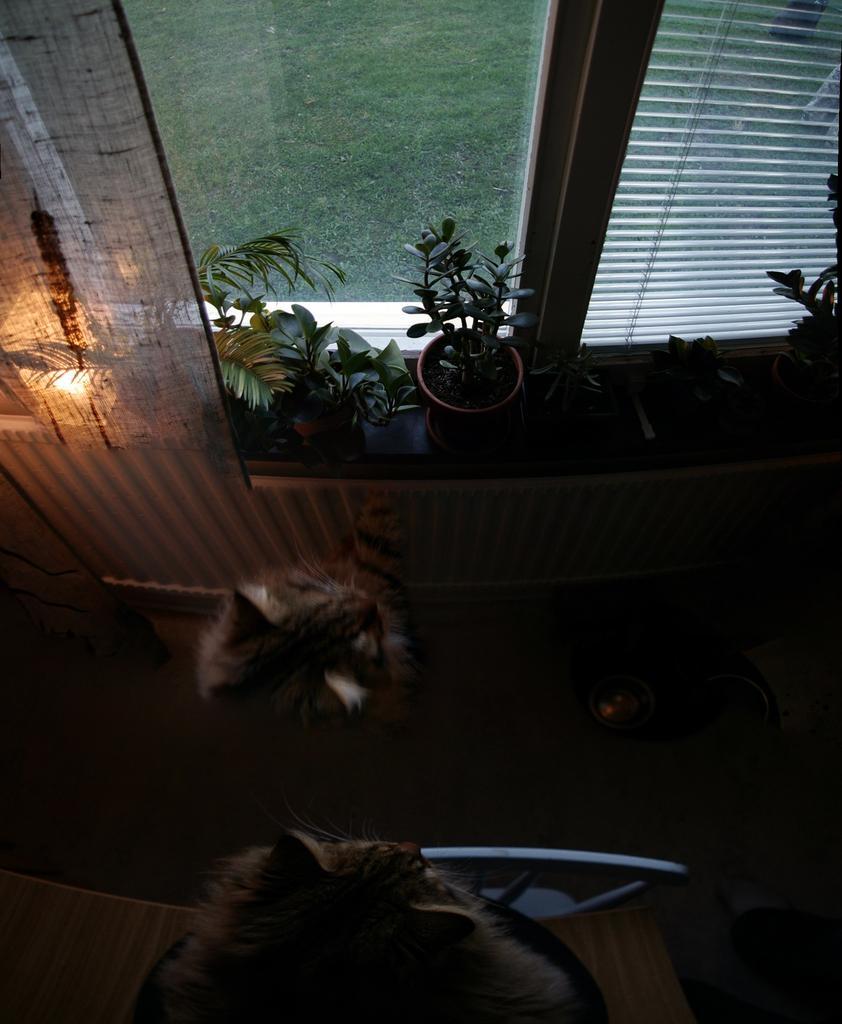Please provide a concise description of this image. In this image there is an animal on the floor having few objects. Bottom of the image there is an animal on the table. Beside the table there is a chair. Few photos are kept on the shelf which is near the window. From the window grassland is visible. The window is covered with a curtain. 